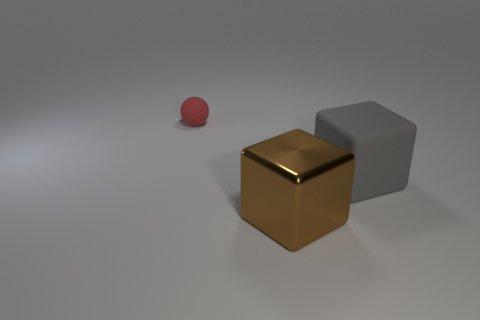How many spheres are either gray matte objects or red matte objects?
Provide a short and direct response. 1. Does the large gray cube have the same material as the brown object?
Keep it short and to the point. No. What number of other objects are there of the same color as the rubber ball?
Give a very brief answer. 0. What shape is the large thing to the right of the brown metal thing?
Make the answer very short. Cube. How many objects are either small red metallic cubes or brown metal blocks?
Provide a short and direct response. 1. There is a gray thing; does it have the same size as the red rubber object that is behind the large gray thing?
Keep it short and to the point. No. What number of other things are there of the same material as the brown thing
Offer a terse response. 0. How many objects are rubber things in front of the red matte object or cubes that are behind the large brown object?
Your response must be concise. 1. What is the material of the other large gray object that is the same shape as the big metal thing?
Offer a terse response. Rubber. Is there a gray rubber thing?
Give a very brief answer. Yes. 